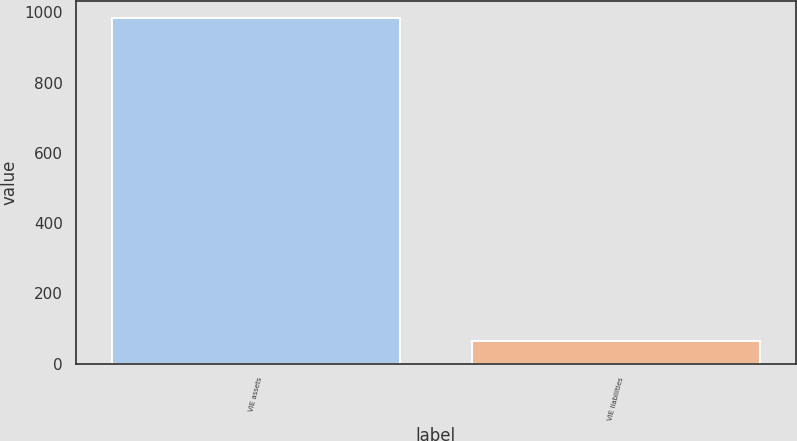<chart> <loc_0><loc_0><loc_500><loc_500><bar_chart><fcel>VIE assets<fcel>VIE liabilities<nl><fcel>983<fcel>65<nl></chart> 